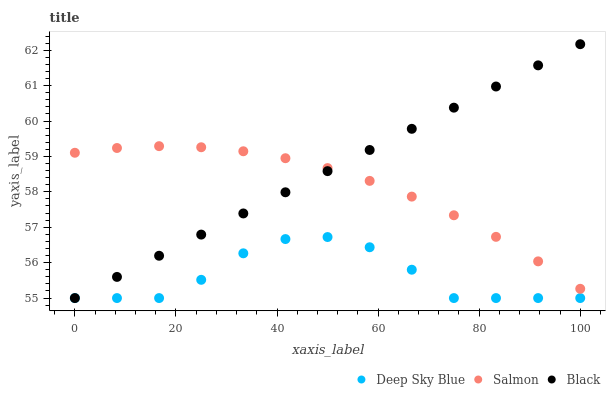Does Deep Sky Blue have the minimum area under the curve?
Answer yes or no. Yes. Does Black have the maximum area under the curve?
Answer yes or no. Yes. Does Salmon have the minimum area under the curve?
Answer yes or no. No. Does Salmon have the maximum area under the curve?
Answer yes or no. No. Is Black the smoothest?
Answer yes or no. Yes. Is Deep Sky Blue the roughest?
Answer yes or no. Yes. Is Salmon the smoothest?
Answer yes or no. No. Is Salmon the roughest?
Answer yes or no. No. Does Black have the lowest value?
Answer yes or no. Yes. Does Salmon have the lowest value?
Answer yes or no. No. Does Black have the highest value?
Answer yes or no. Yes. Does Salmon have the highest value?
Answer yes or no. No. Is Deep Sky Blue less than Salmon?
Answer yes or no. Yes. Is Salmon greater than Deep Sky Blue?
Answer yes or no. Yes. Does Deep Sky Blue intersect Black?
Answer yes or no. Yes. Is Deep Sky Blue less than Black?
Answer yes or no. No. Is Deep Sky Blue greater than Black?
Answer yes or no. No. Does Deep Sky Blue intersect Salmon?
Answer yes or no. No. 